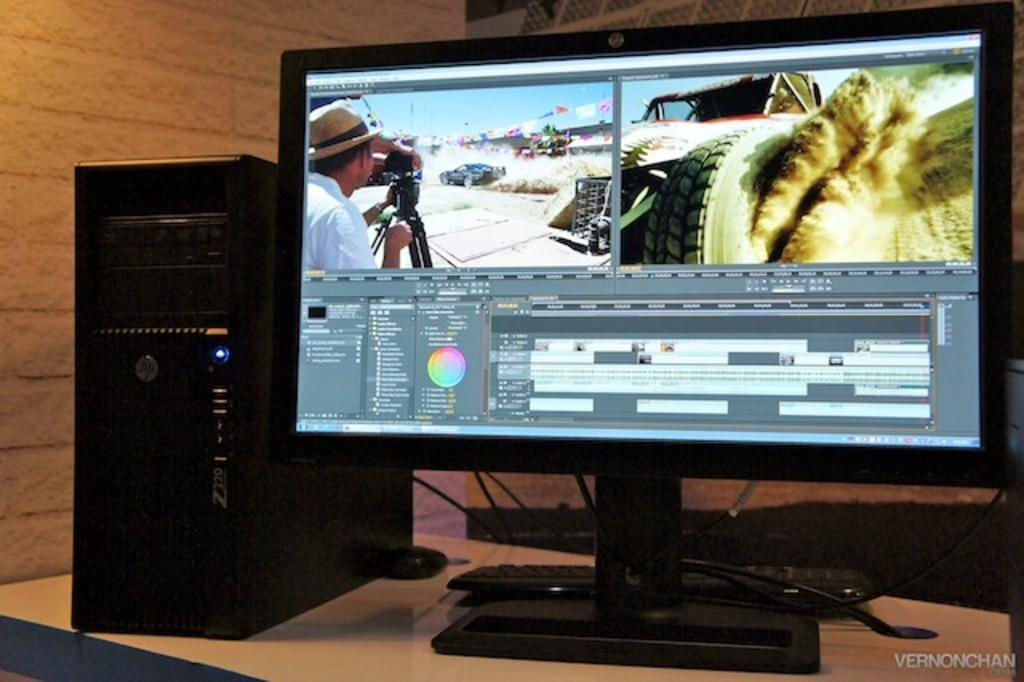<image>
Create a compact narrative representing the image presented. A picture of a monitor and tower computer with the name VernonChani on the bottom right. 